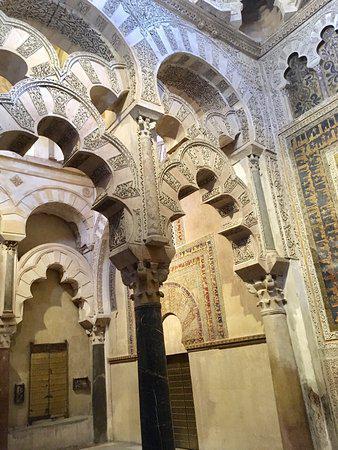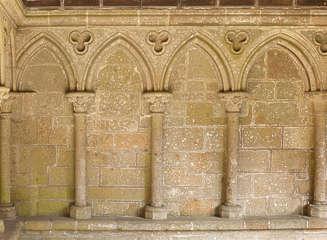The first image is the image on the left, the second image is the image on the right. Evaluate the accuracy of this statement regarding the images: "The right image has no more than 4 arches.". Is it true? Answer yes or no. Yes. 